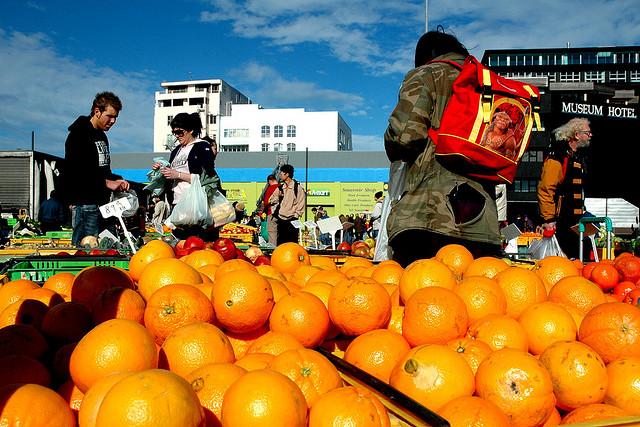Is this a farmer's market?
Write a very short answer. Yes. Is he selling the oranges?
Concise answer only. Yes. How many different fruits are visible in the scene?
Write a very short answer. 4. What is this lady's job?
Keep it brief. Vendor. What is the fruit?
Keep it brief. Oranges. Is this a urban setting?
Give a very brief answer. Yes. Are these oranges for sale?
Short answer required. Yes. 